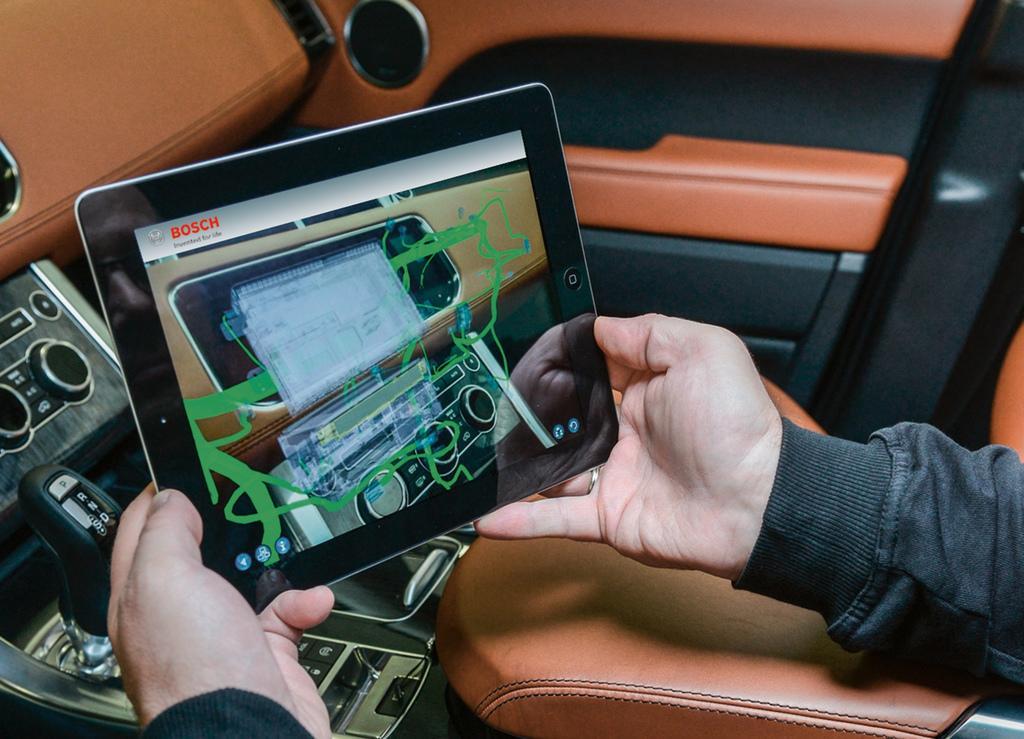Describe this image in one or two sentences. In this image we can see a tab in the person's hand and the person is inside the car. We can see gear rod, buttons and side door. 